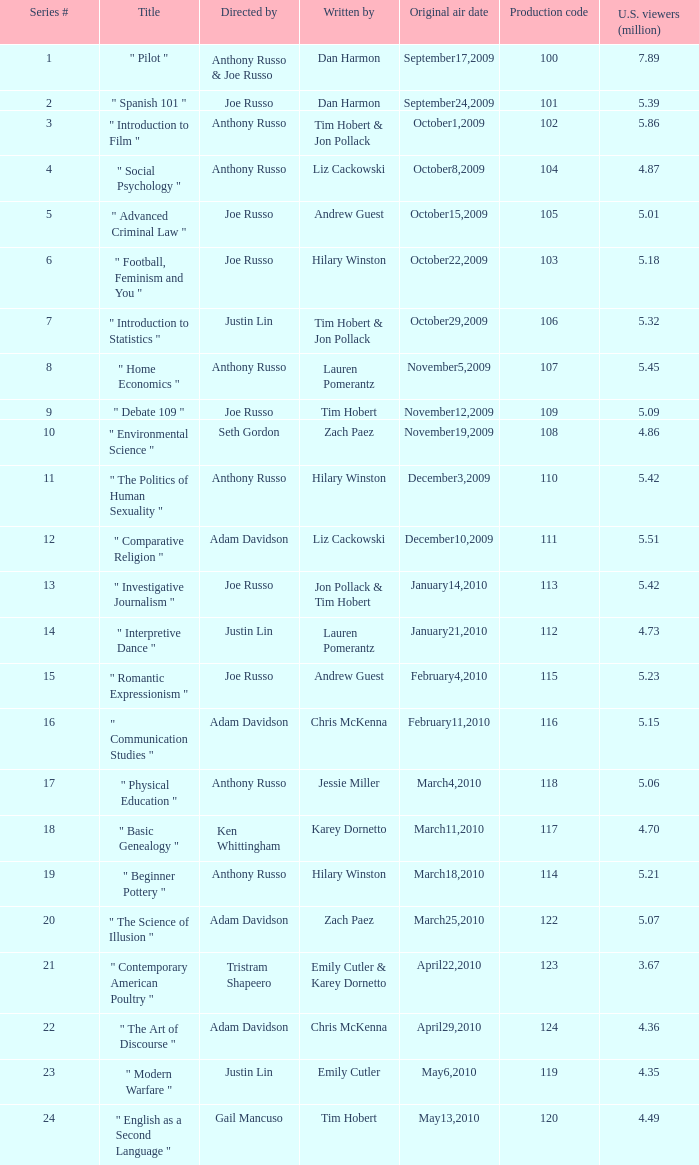What is the label of the series # 8? " Home Economics ". 